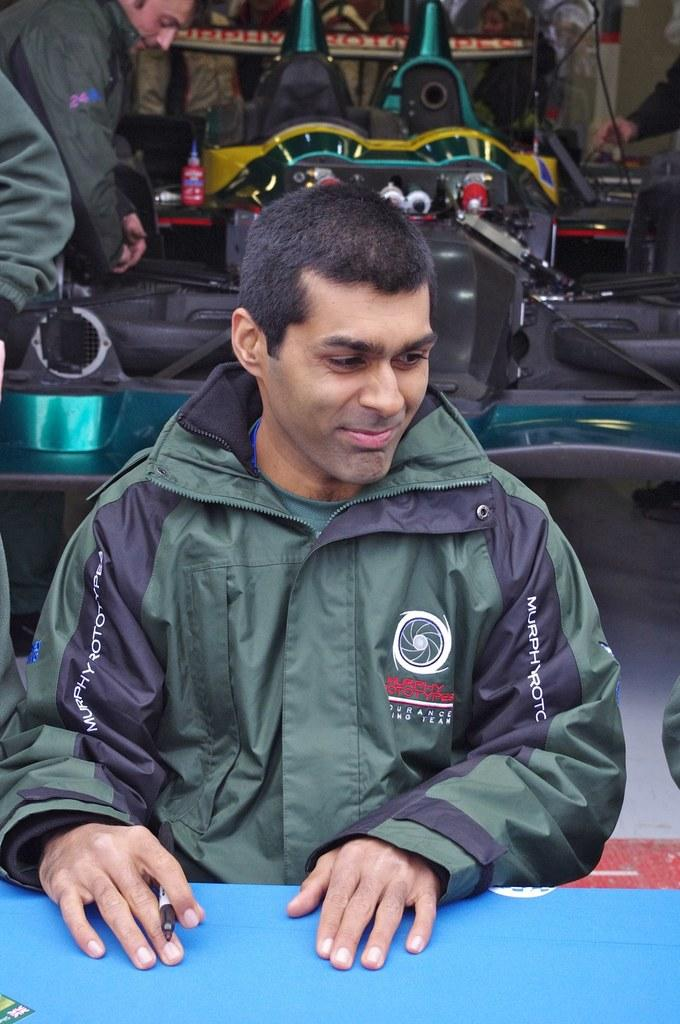Who is present in the image? There is a man in the image. What is the man doing in the image? The man is smiling in the image. What is the man holding in his hand? The man is holding a pen in his hand. What can be seen in the background of the image? There are persons and objects in the background of the image. What grade is the man receiving in the image? There is no indication in the image that the man is receiving a grade, as the facts provided do not mention any educational context. 